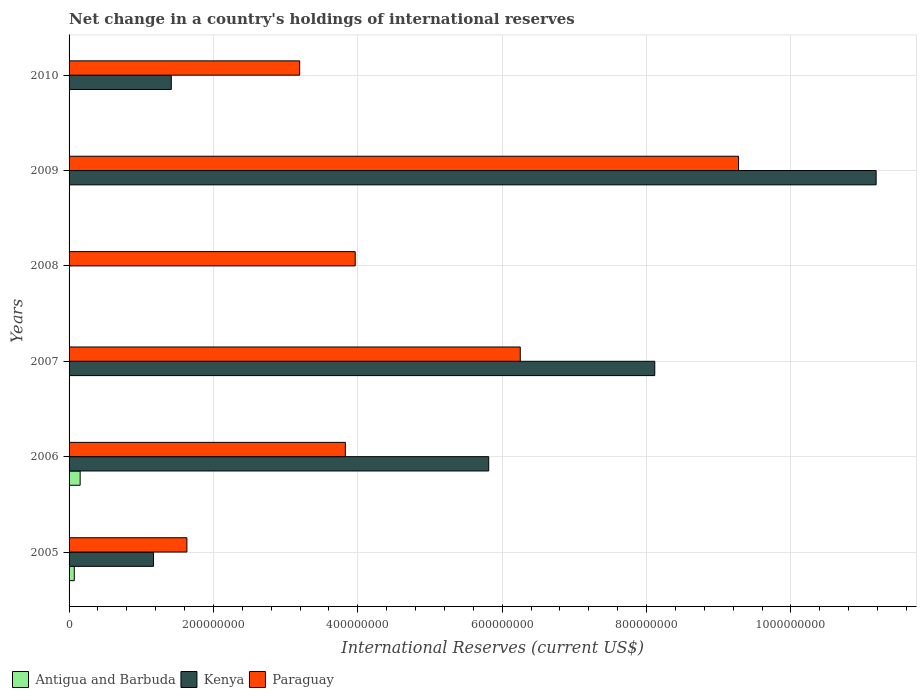How many different coloured bars are there?
Your answer should be compact. 3. Are the number of bars per tick equal to the number of legend labels?
Provide a succinct answer. No. Are the number of bars on each tick of the Y-axis equal?
Keep it short and to the point. No. What is the international reserves in Kenya in 2005?
Ensure brevity in your answer.  1.17e+08. Across all years, what is the maximum international reserves in Kenya?
Your answer should be very brief. 1.12e+09. In which year was the international reserves in Paraguay maximum?
Your answer should be compact. 2009. What is the total international reserves in Paraguay in the graph?
Make the answer very short. 2.81e+09. What is the difference between the international reserves in Kenya in 2005 and that in 2009?
Give a very brief answer. -1.00e+09. What is the difference between the international reserves in Paraguay in 2010 and the international reserves in Kenya in 2007?
Make the answer very short. -4.92e+08. What is the average international reserves in Paraguay per year?
Ensure brevity in your answer.  4.69e+08. In the year 2007, what is the difference between the international reserves in Paraguay and international reserves in Antigua and Barbuda?
Your answer should be very brief. 6.25e+08. What is the ratio of the international reserves in Kenya in 2005 to that in 2009?
Your response must be concise. 0.1. What is the difference between the highest and the second highest international reserves in Kenya?
Your answer should be very brief. 3.07e+08. What is the difference between the highest and the lowest international reserves in Antigua and Barbuda?
Give a very brief answer. 1.54e+07. Is the sum of the international reserves in Kenya in 2005 and 2010 greater than the maximum international reserves in Paraguay across all years?
Give a very brief answer. No. How many bars are there?
Give a very brief answer. 14. How many years are there in the graph?
Make the answer very short. 6. What is the difference between two consecutive major ticks on the X-axis?
Your response must be concise. 2.00e+08. Does the graph contain any zero values?
Offer a very short reply. Yes. Does the graph contain grids?
Your answer should be compact. Yes. What is the title of the graph?
Make the answer very short. Net change in a country's holdings of international reserves. What is the label or title of the X-axis?
Make the answer very short. International Reserves (current US$). What is the International Reserves (current US$) in Antigua and Barbuda in 2005?
Your answer should be compact. 7.24e+06. What is the International Reserves (current US$) of Kenya in 2005?
Your answer should be compact. 1.17e+08. What is the International Reserves (current US$) in Paraguay in 2005?
Ensure brevity in your answer.  1.63e+08. What is the International Reserves (current US$) of Antigua and Barbuda in 2006?
Your answer should be compact. 1.54e+07. What is the International Reserves (current US$) in Kenya in 2006?
Make the answer very short. 5.81e+08. What is the International Reserves (current US$) in Paraguay in 2006?
Make the answer very short. 3.83e+08. What is the International Reserves (current US$) in Antigua and Barbuda in 2007?
Provide a succinct answer. 3.68e+05. What is the International Reserves (current US$) of Kenya in 2007?
Your answer should be compact. 8.11e+08. What is the International Reserves (current US$) of Paraguay in 2007?
Give a very brief answer. 6.25e+08. What is the International Reserves (current US$) of Antigua and Barbuda in 2008?
Your response must be concise. 0. What is the International Reserves (current US$) in Kenya in 2008?
Offer a very short reply. 0. What is the International Reserves (current US$) in Paraguay in 2008?
Offer a very short reply. 3.96e+08. What is the International Reserves (current US$) of Kenya in 2009?
Keep it short and to the point. 1.12e+09. What is the International Reserves (current US$) of Paraguay in 2009?
Your response must be concise. 9.27e+08. What is the International Reserves (current US$) of Kenya in 2010?
Provide a succinct answer. 1.42e+08. What is the International Reserves (current US$) in Paraguay in 2010?
Keep it short and to the point. 3.19e+08. Across all years, what is the maximum International Reserves (current US$) in Antigua and Barbuda?
Provide a succinct answer. 1.54e+07. Across all years, what is the maximum International Reserves (current US$) of Kenya?
Provide a succinct answer. 1.12e+09. Across all years, what is the maximum International Reserves (current US$) in Paraguay?
Provide a succinct answer. 9.27e+08. Across all years, what is the minimum International Reserves (current US$) of Paraguay?
Your answer should be compact. 1.63e+08. What is the total International Reserves (current US$) of Antigua and Barbuda in the graph?
Provide a succinct answer. 2.30e+07. What is the total International Reserves (current US$) in Kenya in the graph?
Your answer should be very brief. 2.77e+09. What is the total International Reserves (current US$) of Paraguay in the graph?
Offer a terse response. 2.81e+09. What is the difference between the International Reserves (current US$) of Antigua and Barbuda in 2005 and that in 2006?
Your answer should be compact. -8.13e+06. What is the difference between the International Reserves (current US$) of Kenya in 2005 and that in 2006?
Ensure brevity in your answer.  -4.64e+08. What is the difference between the International Reserves (current US$) in Paraguay in 2005 and that in 2006?
Keep it short and to the point. -2.20e+08. What is the difference between the International Reserves (current US$) in Antigua and Barbuda in 2005 and that in 2007?
Ensure brevity in your answer.  6.87e+06. What is the difference between the International Reserves (current US$) in Kenya in 2005 and that in 2007?
Your answer should be compact. -6.94e+08. What is the difference between the International Reserves (current US$) in Paraguay in 2005 and that in 2007?
Give a very brief answer. -4.62e+08. What is the difference between the International Reserves (current US$) in Paraguay in 2005 and that in 2008?
Keep it short and to the point. -2.33e+08. What is the difference between the International Reserves (current US$) in Kenya in 2005 and that in 2009?
Provide a succinct answer. -1.00e+09. What is the difference between the International Reserves (current US$) in Paraguay in 2005 and that in 2009?
Give a very brief answer. -7.64e+08. What is the difference between the International Reserves (current US$) in Kenya in 2005 and that in 2010?
Your answer should be compact. -2.46e+07. What is the difference between the International Reserves (current US$) in Paraguay in 2005 and that in 2010?
Provide a succinct answer. -1.56e+08. What is the difference between the International Reserves (current US$) in Antigua and Barbuda in 2006 and that in 2007?
Offer a terse response. 1.50e+07. What is the difference between the International Reserves (current US$) in Kenya in 2006 and that in 2007?
Your answer should be very brief. -2.30e+08. What is the difference between the International Reserves (current US$) in Paraguay in 2006 and that in 2007?
Ensure brevity in your answer.  -2.42e+08. What is the difference between the International Reserves (current US$) of Paraguay in 2006 and that in 2008?
Your answer should be very brief. -1.36e+07. What is the difference between the International Reserves (current US$) of Kenya in 2006 and that in 2009?
Your response must be concise. -5.37e+08. What is the difference between the International Reserves (current US$) in Paraguay in 2006 and that in 2009?
Offer a terse response. -5.45e+08. What is the difference between the International Reserves (current US$) of Kenya in 2006 and that in 2010?
Your answer should be compact. 4.40e+08. What is the difference between the International Reserves (current US$) of Paraguay in 2006 and that in 2010?
Offer a terse response. 6.33e+07. What is the difference between the International Reserves (current US$) in Paraguay in 2007 and that in 2008?
Give a very brief answer. 2.29e+08. What is the difference between the International Reserves (current US$) in Kenya in 2007 and that in 2009?
Offer a very short reply. -3.07e+08. What is the difference between the International Reserves (current US$) in Paraguay in 2007 and that in 2009?
Your answer should be very brief. -3.02e+08. What is the difference between the International Reserves (current US$) of Kenya in 2007 and that in 2010?
Offer a terse response. 6.70e+08. What is the difference between the International Reserves (current US$) in Paraguay in 2007 and that in 2010?
Your response must be concise. 3.06e+08. What is the difference between the International Reserves (current US$) in Paraguay in 2008 and that in 2009?
Provide a short and direct response. -5.31e+08. What is the difference between the International Reserves (current US$) in Paraguay in 2008 and that in 2010?
Your answer should be very brief. 7.69e+07. What is the difference between the International Reserves (current US$) in Kenya in 2009 and that in 2010?
Ensure brevity in your answer.  9.76e+08. What is the difference between the International Reserves (current US$) in Paraguay in 2009 and that in 2010?
Offer a terse response. 6.08e+08. What is the difference between the International Reserves (current US$) of Antigua and Barbuda in 2005 and the International Reserves (current US$) of Kenya in 2006?
Your response must be concise. -5.74e+08. What is the difference between the International Reserves (current US$) in Antigua and Barbuda in 2005 and the International Reserves (current US$) in Paraguay in 2006?
Keep it short and to the point. -3.75e+08. What is the difference between the International Reserves (current US$) in Kenya in 2005 and the International Reserves (current US$) in Paraguay in 2006?
Give a very brief answer. -2.66e+08. What is the difference between the International Reserves (current US$) of Antigua and Barbuda in 2005 and the International Reserves (current US$) of Kenya in 2007?
Your response must be concise. -8.04e+08. What is the difference between the International Reserves (current US$) in Antigua and Barbuda in 2005 and the International Reserves (current US$) in Paraguay in 2007?
Your answer should be very brief. -6.18e+08. What is the difference between the International Reserves (current US$) of Kenya in 2005 and the International Reserves (current US$) of Paraguay in 2007?
Your response must be concise. -5.08e+08. What is the difference between the International Reserves (current US$) of Antigua and Barbuda in 2005 and the International Reserves (current US$) of Paraguay in 2008?
Give a very brief answer. -3.89e+08. What is the difference between the International Reserves (current US$) of Kenya in 2005 and the International Reserves (current US$) of Paraguay in 2008?
Provide a short and direct response. -2.79e+08. What is the difference between the International Reserves (current US$) of Antigua and Barbuda in 2005 and the International Reserves (current US$) of Kenya in 2009?
Provide a succinct answer. -1.11e+09. What is the difference between the International Reserves (current US$) of Antigua and Barbuda in 2005 and the International Reserves (current US$) of Paraguay in 2009?
Provide a succinct answer. -9.20e+08. What is the difference between the International Reserves (current US$) of Kenya in 2005 and the International Reserves (current US$) of Paraguay in 2009?
Your answer should be compact. -8.10e+08. What is the difference between the International Reserves (current US$) in Antigua and Barbuda in 2005 and the International Reserves (current US$) in Kenya in 2010?
Your answer should be very brief. -1.34e+08. What is the difference between the International Reserves (current US$) in Antigua and Barbuda in 2005 and the International Reserves (current US$) in Paraguay in 2010?
Your answer should be compact. -3.12e+08. What is the difference between the International Reserves (current US$) in Kenya in 2005 and the International Reserves (current US$) in Paraguay in 2010?
Offer a terse response. -2.02e+08. What is the difference between the International Reserves (current US$) in Antigua and Barbuda in 2006 and the International Reserves (current US$) in Kenya in 2007?
Your answer should be compact. -7.96e+08. What is the difference between the International Reserves (current US$) of Antigua and Barbuda in 2006 and the International Reserves (current US$) of Paraguay in 2007?
Your answer should be very brief. -6.10e+08. What is the difference between the International Reserves (current US$) in Kenya in 2006 and the International Reserves (current US$) in Paraguay in 2007?
Provide a succinct answer. -4.37e+07. What is the difference between the International Reserves (current US$) of Antigua and Barbuda in 2006 and the International Reserves (current US$) of Paraguay in 2008?
Keep it short and to the point. -3.81e+08. What is the difference between the International Reserves (current US$) of Kenya in 2006 and the International Reserves (current US$) of Paraguay in 2008?
Provide a short and direct response. 1.85e+08. What is the difference between the International Reserves (current US$) of Antigua and Barbuda in 2006 and the International Reserves (current US$) of Kenya in 2009?
Provide a succinct answer. -1.10e+09. What is the difference between the International Reserves (current US$) in Antigua and Barbuda in 2006 and the International Reserves (current US$) in Paraguay in 2009?
Your answer should be compact. -9.12e+08. What is the difference between the International Reserves (current US$) of Kenya in 2006 and the International Reserves (current US$) of Paraguay in 2009?
Your answer should be compact. -3.46e+08. What is the difference between the International Reserves (current US$) of Antigua and Barbuda in 2006 and the International Reserves (current US$) of Kenya in 2010?
Keep it short and to the point. -1.26e+08. What is the difference between the International Reserves (current US$) of Antigua and Barbuda in 2006 and the International Reserves (current US$) of Paraguay in 2010?
Provide a short and direct response. -3.04e+08. What is the difference between the International Reserves (current US$) of Kenya in 2006 and the International Reserves (current US$) of Paraguay in 2010?
Provide a succinct answer. 2.62e+08. What is the difference between the International Reserves (current US$) in Antigua and Barbuda in 2007 and the International Reserves (current US$) in Paraguay in 2008?
Provide a short and direct response. -3.96e+08. What is the difference between the International Reserves (current US$) of Kenya in 2007 and the International Reserves (current US$) of Paraguay in 2008?
Your response must be concise. 4.15e+08. What is the difference between the International Reserves (current US$) in Antigua and Barbuda in 2007 and the International Reserves (current US$) in Kenya in 2009?
Ensure brevity in your answer.  -1.12e+09. What is the difference between the International Reserves (current US$) of Antigua and Barbuda in 2007 and the International Reserves (current US$) of Paraguay in 2009?
Offer a very short reply. -9.27e+08. What is the difference between the International Reserves (current US$) in Kenya in 2007 and the International Reserves (current US$) in Paraguay in 2009?
Your response must be concise. -1.16e+08. What is the difference between the International Reserves (current US$) of Antigua and Barbuda in 2007 and the International Reserves (current US$) of Kenya in 2010?
Ensure brevity in your answer.  -1.41e+08. What is the difference between the International Reserves (current US$) of Antigua and Barbuda in 2007 and the International Reserves (current US$) of Paraguay in 2010?
Provide a short and direct response. -3.19e+08. What is the difference between the International Reserves (current US$) in Kenya in 2007 and the International Reserves (current US$) in Paraguay in 2010?
Give a very brief answer. 4.92e+08. What is the difference between the International Reserves (current US$) in Kenya in 2009 and the International Reserves (current US$) in Paraguay in 2010?
Provide a succinct answer. 7.99e+08. What is the average International Reserves (current US$) of Antigua and Barbuda per year?
Your answer should be compact. 3.83e+06. What is the average International Reserves (current US$) in Kenya per year?
Provide a succinct answer. 4.62e+08. What is the average International Reserves (current US$) of Paraguay per year?
Offer a terse response. 4.69e+08. In the year 2005, what is the difference between the International Reserves (current US$) of Antigua and Barbuda and International Reserves (current US$) of Kenya?
Provide a succinct answer. -1.10e+08. In the year 2005, what is the difference between the International Reserves (current US$) in Antigua and Barbuda and International Reserves (current US$) in Paraguay?
Ensure brevity in your answer.  -1.56e+08. In the year 2005, what is the difference between the International Reserves (current US$) in Kenya and International Reserves (current US$) in Paraguay?
Offer a terse response. -4.62e+07. In the year 2006, what is the difference between the International Reserves (current US$) in Antigua and Barbuda and International Reserves (current US$) in Kenya?
Your answer should be compact. -5.66e+08. In the year 2006, what is the difference between the International Reserves (current US$) of Antigua and Barbuda and International Reserves (current US$) of Paraguay?
Keep it short and to the point. -3.67e+08. In the year 2006, what is the difference between the International Reserves (current US$) of Kenya and International Reserves (current US$) of Paraguay?
Your response must be concise. 1.99e+08. In the year 2007, what is the difference between the International Reserves (current US$) of Antigua and Barbuda and International Reserves (current US$) of Kenya?
Keep it short and to the point. -8.11e+08. In the year 2007, what is the difference between the International Reserves (current US$) in Antigua and Barbuda and International Reserves (current US$) in Paraguay?
Offer a terse response. -6.25e+08. In the year 2007, what is the difference between the International Reserves (current US$) of Kenya and International Reserves (current US$) of Paraguay?
Provide a short and direct response. 1.86e+08. In the year 2009, what is the difference between the International Reserves (current US$) of Kenya and International Reserves (current US$) of Paraguay?
Your answer should be very brief. 1.91e+08. In the year 2010, what is the difference between the International Reserves (current US$) of Kenya and International Reserves (current US$) of Paraguay?
Keep it short and to the point. -1.78e+08. What is the ratio of the International Reserves (current US$) in Antigua and Barbuda in 2005 to that in 2006?
Provide a short and direct response. 0.47. What is the ratio of the International Reserves (current US$) in Kenya in 2005 to that in 2006?
Give a very brief answer. 0.2. What is the ratio of the International Reserves (current US$) of Paraguay in 2005 to that in 2006?
Offer a terse response. 0.43. What is the ratio of the International Reserves (current US$) of Antigua and Barbuda in 2005 to that in 2007?
Give a very brief answer. 19.64. What is the ratio of the International Reserves (current US$) in Kenya in 2005 to that in 2007?
Make the answer very short. 0.14. What is the ratio of the International Reserves (current US$) of Paraguay in 2005 to that in 2007?
Ensure brevity in your answer.  0.26. What is the ratio of the International Reserves (current US$) of Paraguay in 2005 to that in 2008?
Your answer should be compact. 0.41. What is the ratio of the International Reserves (current US$) in Kenya in 2005 to that in 2009?
Your response must be concise. 0.1. What is the ratio of the International Reserves (current US$) in Paraguay in 2005 to that in 2009?
Keep it short and to the point. 0.18. What is the ratio of the International Reserves (current US$) in Kenya in 2005 to that in 2010?
Your response must be concise. 0.83. What is the ratio of the International Reserves (current US$) of Paraguay in 2005 to that in 2010?
Provide a short and direct response. 0.51. What is the ratio of the International Reserves (current US$) in Antigua and Barbuda in 2006 to that in 2007?
Your response must be concise. 41.69. What is the ratio of the International Reserves (current US$) of Kenya in 2006 to that in 2007?
Keep it short and to the point. 0.72. What is the ratio of the International Reserves (current US$) of Paraguay in 2006 to that in 2007?
Make the answer very short. 0.61. What is the ratio of the International Reserves (current US$) of Paraguay in 2006 to that in 2008?
Give a very brief answer. 0.97. What is the ratio of the International Reserves (current US$) in Kenya in 2006 to that in 2009?
Give a very brief answer. 0.52. What is the ratio of the International Reserves (current US$) in Paraguay in 2006 to that in 2009?
Provide a short and direct response. 0.41. What is the ratio of the International Reserves (current US$) in Kenya in 2006 to that in 2010?
Ensure brevity in your answer.  4.11. What is the ratio of the International Reserves (current US$) in Paraguay in 2006 to that in 2010?
Provide a short and direct response. 1.2. What is the ratio of the International Reserves (current US$) in Paraguay in 2007 to that in 2008?
Offer a terse response. 1.58. What is the ratio of the International Reserves (current US$) in Kenya in 2007 to that in 2009?
Your answer should be compact. 0.73. What is the ratio of the International Reserves (current US$) in Paraguay in 2007 to that in 2009?
Keep it short and to the point. 0.67. What is the ratio of the International Reserves (current US$) in Kenya in 2007 to that in 2010?
Provide a succinct answer. 5.73. What is the ratio of the International Reserves (current US$) in Paraguay in 2007 to that in 2010?
Make the answer very short. 1.96. What is the ratio of the International Reserves (current US$) in Paraguay in 2008 to that in 2009?
Your answer should be compact. 0.43. What is the ratio of the International Reserves (current US$) of Paraguay in 2008 to that in 2010?
Your answer should be compact. 1.24. What is the ratio of the International Reserves (current US$) in Kenya in 2009 to that in 2010?
Your answer should be very brief. 7.9. What is the ratio of the International Reserves (current US$) in Paraguay in 2009 to that in 2010?
Offer a very short reply. 2.9. What is the difference between the highest and the second highest International Reserves (current US$) in Antigua and Barbuda?
Give a very brief answer. 8.13e+06. What is the difference between the highest and the second highest International Reserves (current US$) in Kenya?
Provide a short and direct response. 3.07e+08. What is the difference between the highest and the second highest International Reserves (current US$) in Paraguay?
Give a very brief answer. 3.02e+08. What is the difference between the highest and the lowest International Reserves (current US$) in Antigua and Barbuda?
Make the answer very short. 1.54e+07. What is the difference between the highest and the lowest International Reserves (current US$) in Kenya?
Ensure brevity in your answer.  1.12e+09. What is the difference between the highest and the lowest International Reserves (current US$) of Paraguay?
Ensure brevity in your answer.  7.64e+08. 